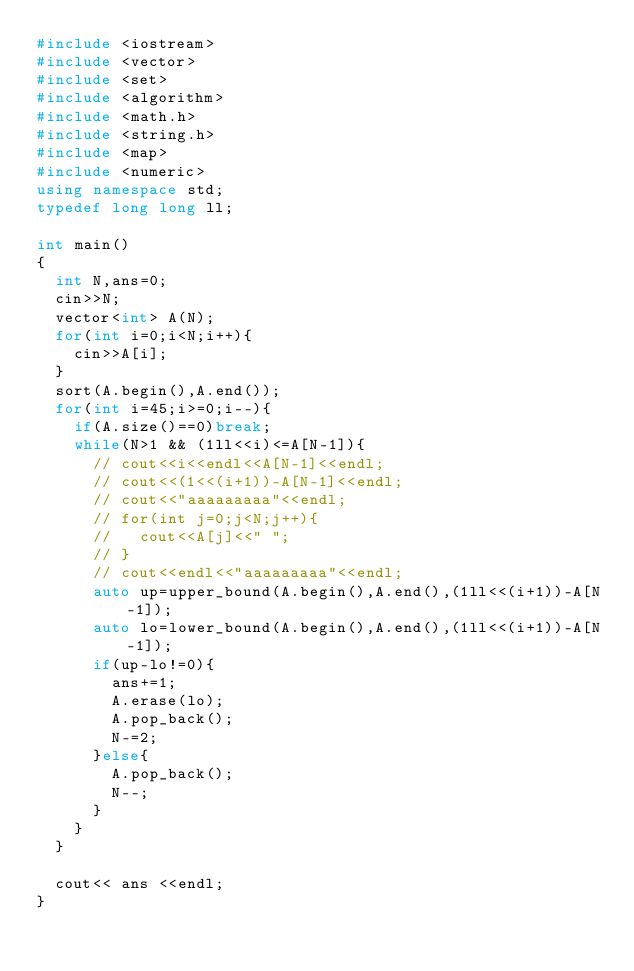<code> <loc_0><loc_0><loc_500><loc_500><_C++_>#include <iostream>
#include <vector>
#include <set>
#include <algorithm>
#include <math.h>
#include <string.h>
#include <map>
#include <numeric>
using namespace std;
typedef long long ll;

int main()
{
  int N,ans=0;
  cin>>N;
  vector<int> A(N);
  for(int i=0;i<N;i++){
    cin>>A[i];
  }
  sort(A.begin(),A.end());
  for(int i=45;i>=0;i--){
    if(A.size()==0)break;
    while(N>1 && (1ll<<i)<=A[N-1]){
      // cout<<i<<endl<<A[N-1]<<endl;
      // cout<<(1<<(i+1))-A[N-1]<<endl;
      // cout<<"aaaaaaaaa"<<endl;
      // for(int j=0;j<N;j++){
      //   cout<<A[j]<<" ";
      // }
      // cout<<endl<<"aaaaaaaaa"<<endl;
      auto up=upper_bound(A.begin(),A.end(),(1ll<<(i+1))-A[N-1]);
      auto lo=lower_bound(A.begin(),A.end(),(1ll<<(i+1))-A[N-1]);
      if(up-lo!=0){
        ans+=1;
        A.erase(lo);
        A.pop_back();
        N-=2;
      }else{
        A.pop_back();
        N--;
      }
    }
  }

  cout<< ans <<endl;
}
</code> 